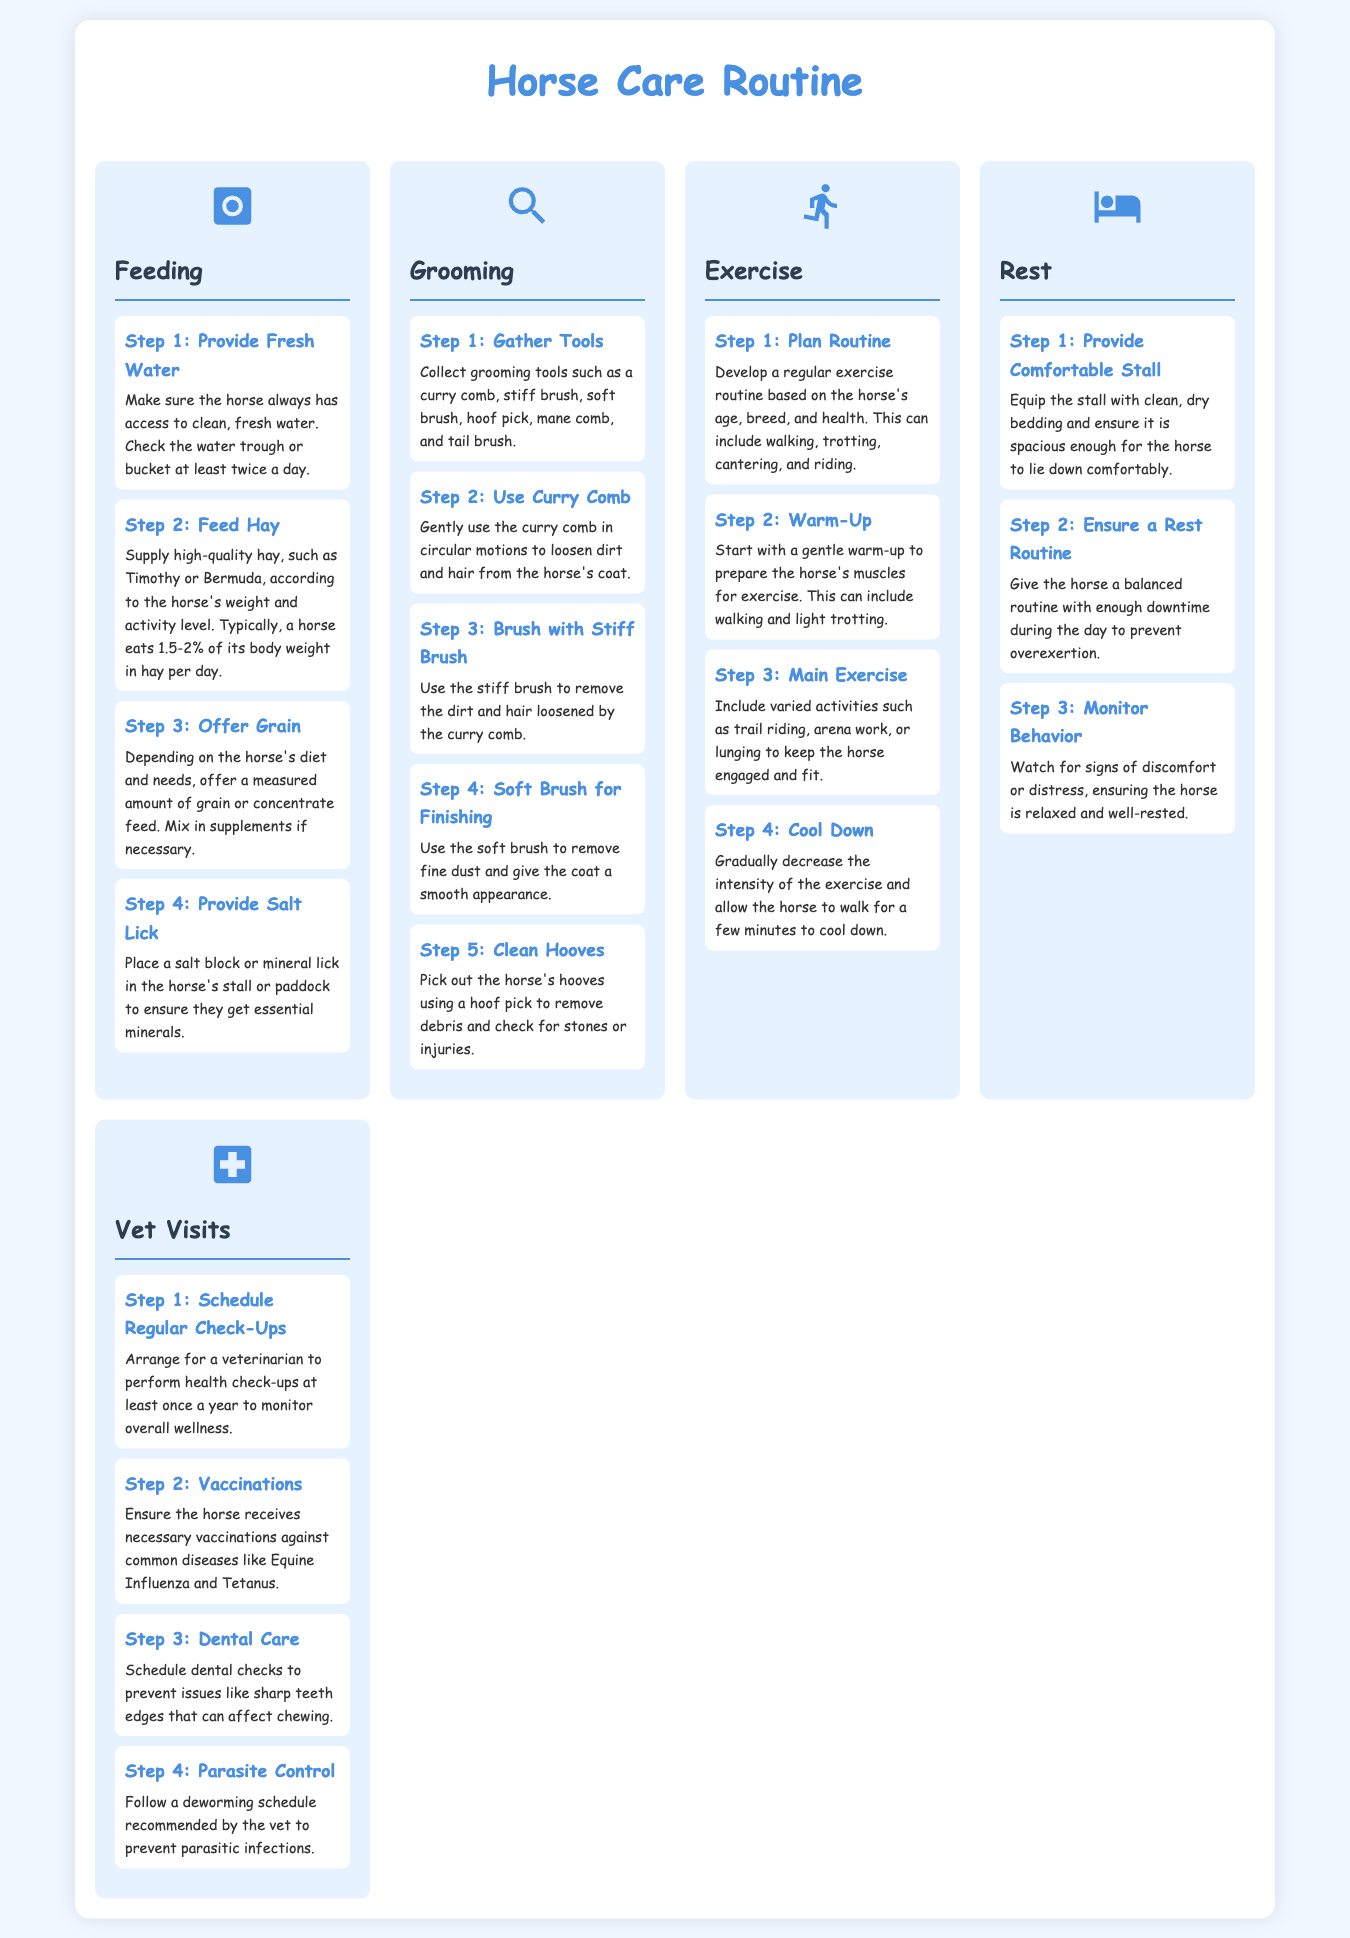What should be provided first in the feeding routine? The document states that fresh water should be provided first in the feeding routine.
Answer: Fresh water How many steps are there in the grooming section? The grooming section contains a total of five steps as listed in the document.
Answer: Five steps What is the recommended percentage of body weight in hay per day? The document suggests that a horse eats 1.5-2% of its body weight in hay per day.
Answer: 1.5-2% What should be used to loosen dirt and hair from the horse's coat? The document advises using a curry comb to loosen dirt and hair from the coat.
Answer: Curry comb How often should vet check-ups be scheduled? According to the document, veterinarian check-ups should be scheduled at least once a year.
Answer: Once a year What is the main activity included in the exercise section? The main activity mentioned in the exercise section includes varied activities like trail riding and arena work.
Answer: Trail riding What type of bedding should the stall be equipped with? The document states that the stall should be equipped with clean, dry bedding for the horse.
Answer: Clean, dry bedding What is the purpose of the salt lick? The document explains that a salt lick provides essential minerals to the horse.
Answer: Essential minerals Which grooming tool is used for removing fine dust? The document mentions that a soft brush is used for removing fine dust from the horse's coat.
Answer: Soft brush 